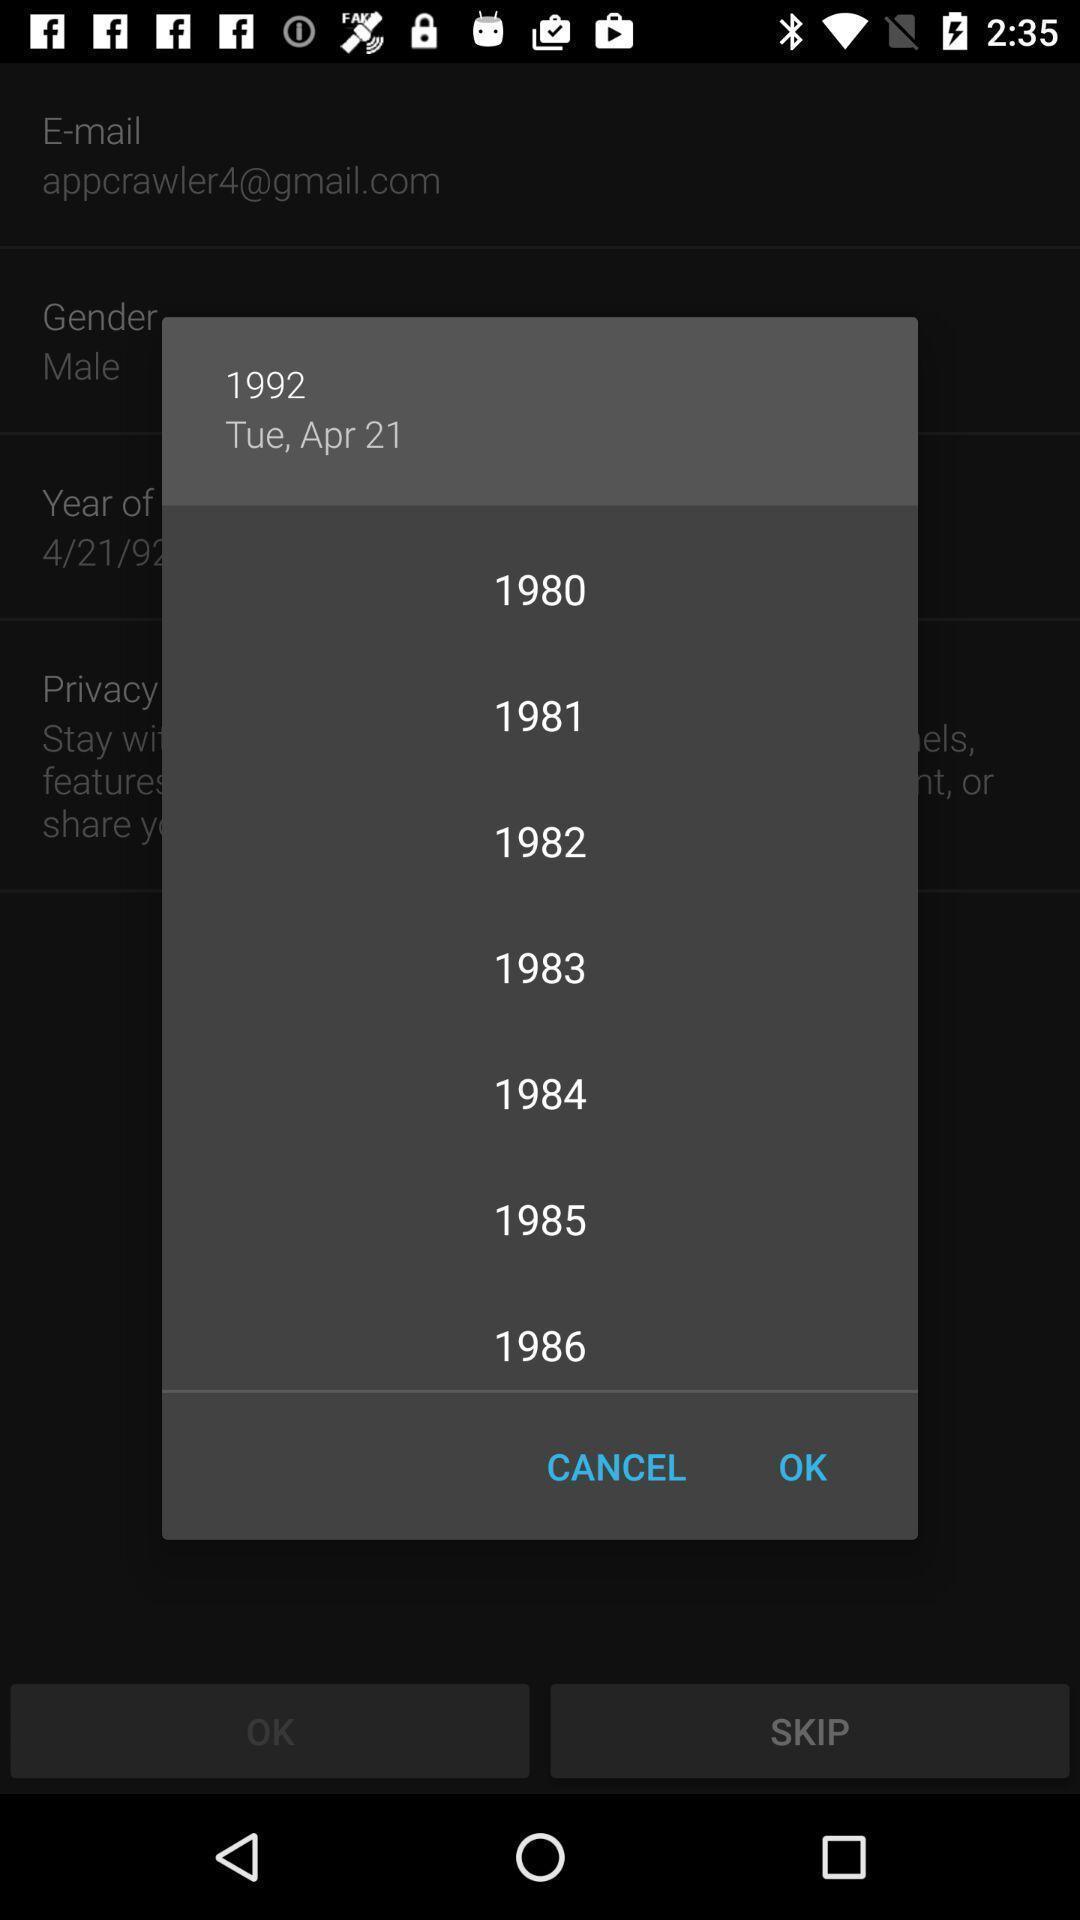Explain the elements present in this screenshot. Push up displaying list of years. 